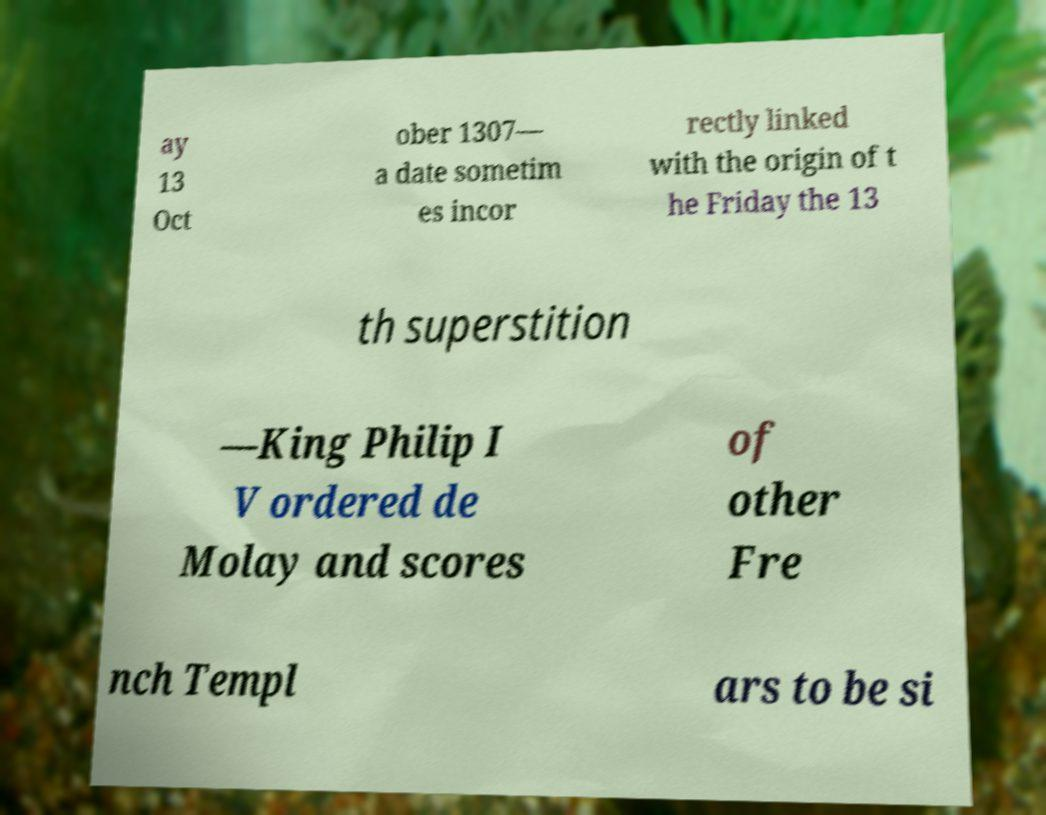There's text embedded in this image that I need extracted. Can you transcribe it verbatim? ay 13 Oct ober 1307— a date sometim es incor rectly linked with the origin of t he Friday the 13 th superstition —King Philip I V ordered de Molay and scores of other Fre nch Templ ars to be si 